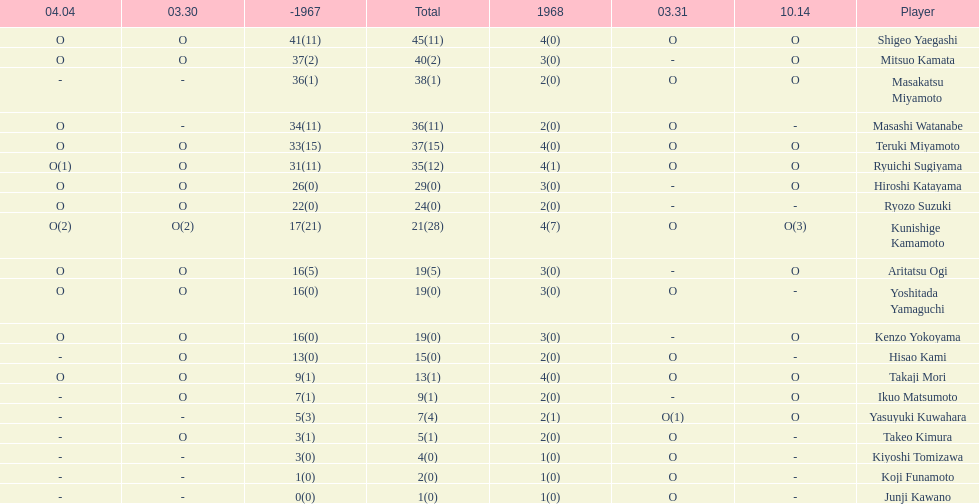How many points did takaji mori have? 13(1). And how many points did junji kawano have? 1(0). To who does the higher of these belong to? Takaji Mori. 